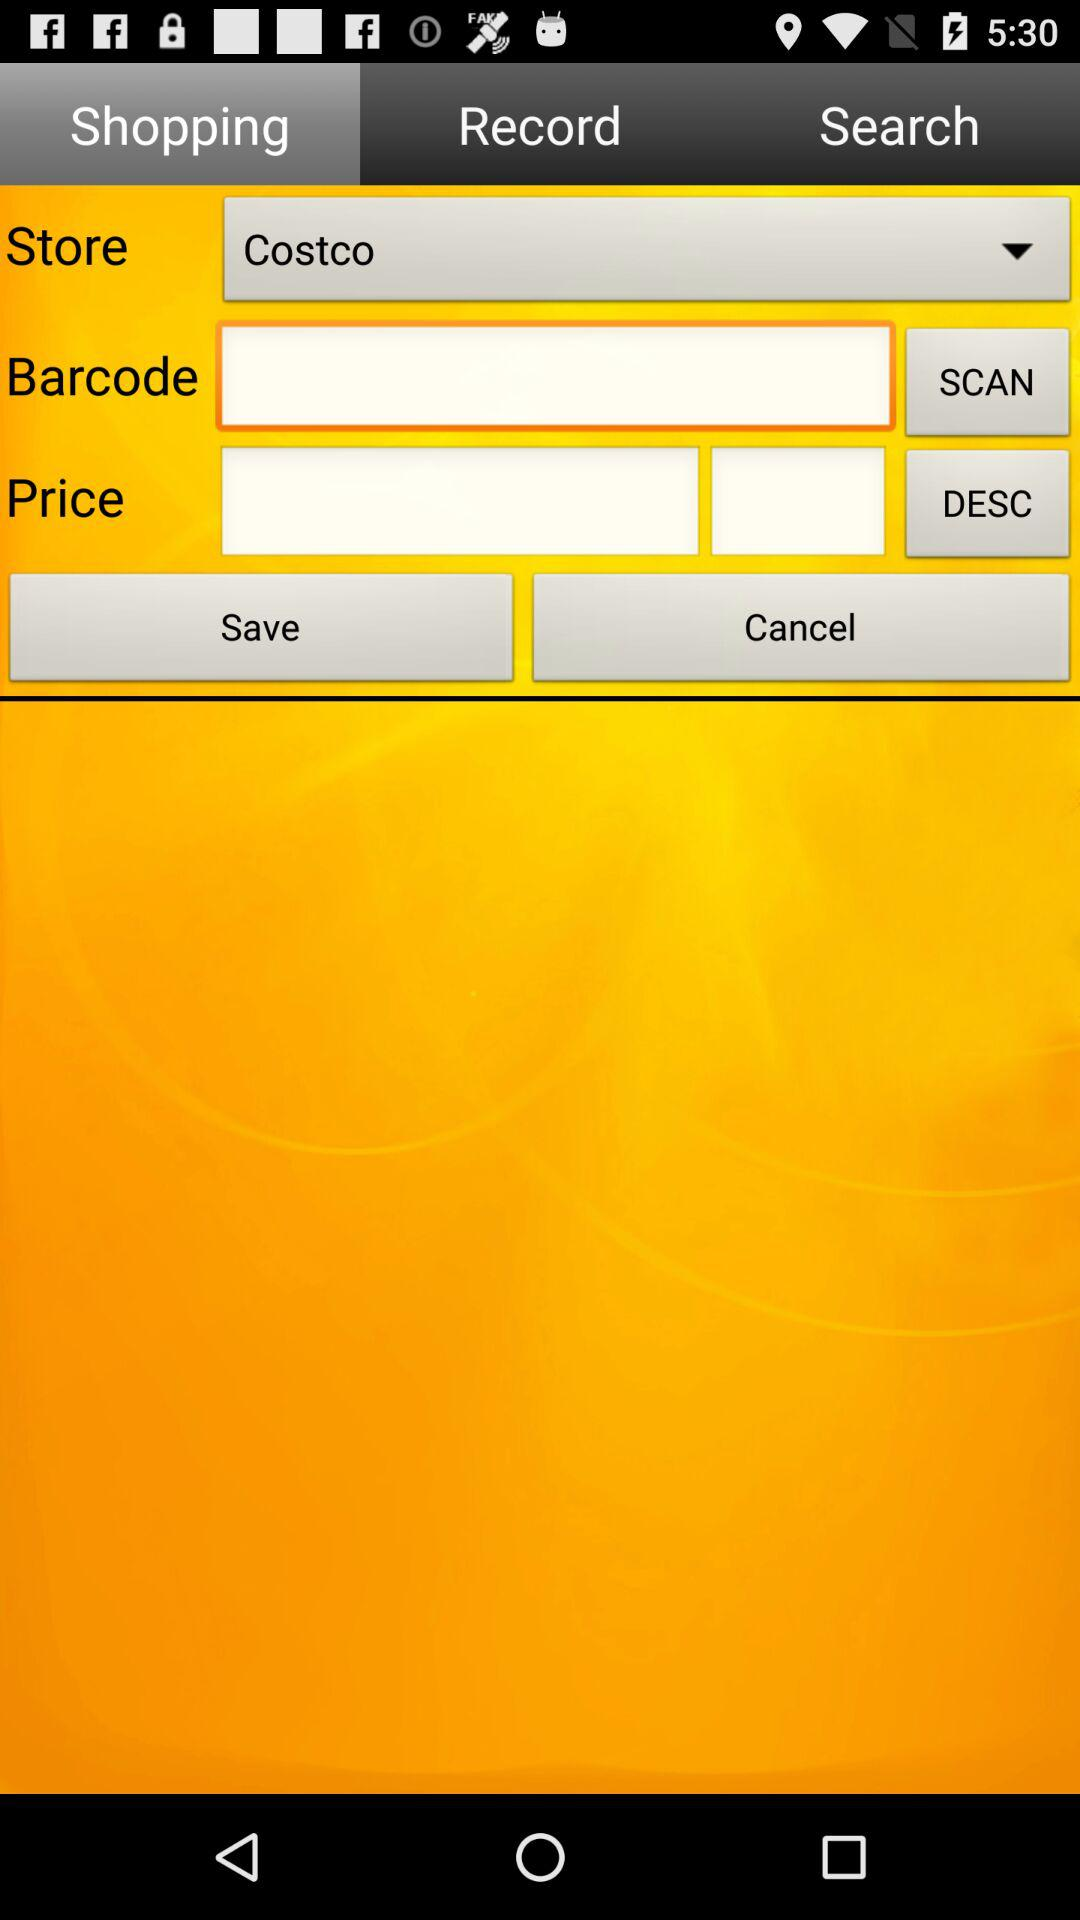What option for "Store" is selected? The selected option is "Costco". 